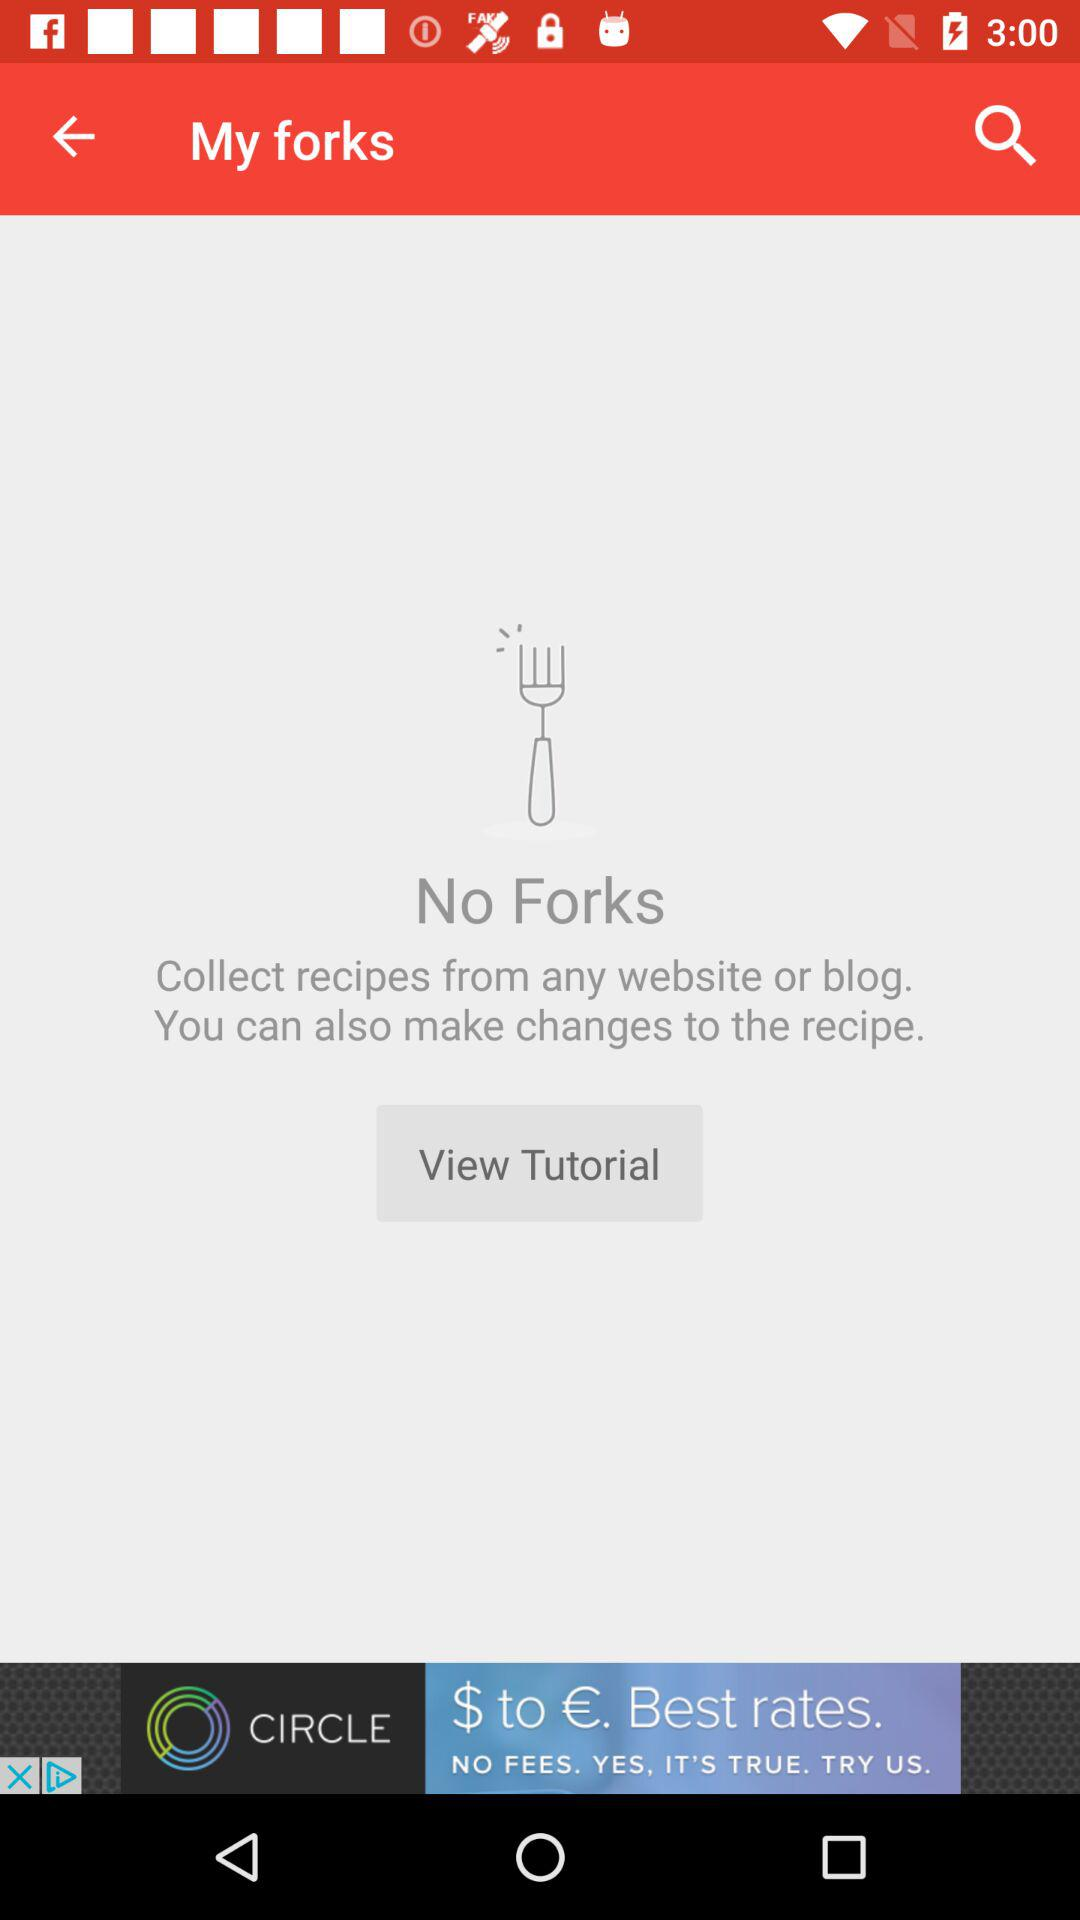Are there any forks? There are no forks. 